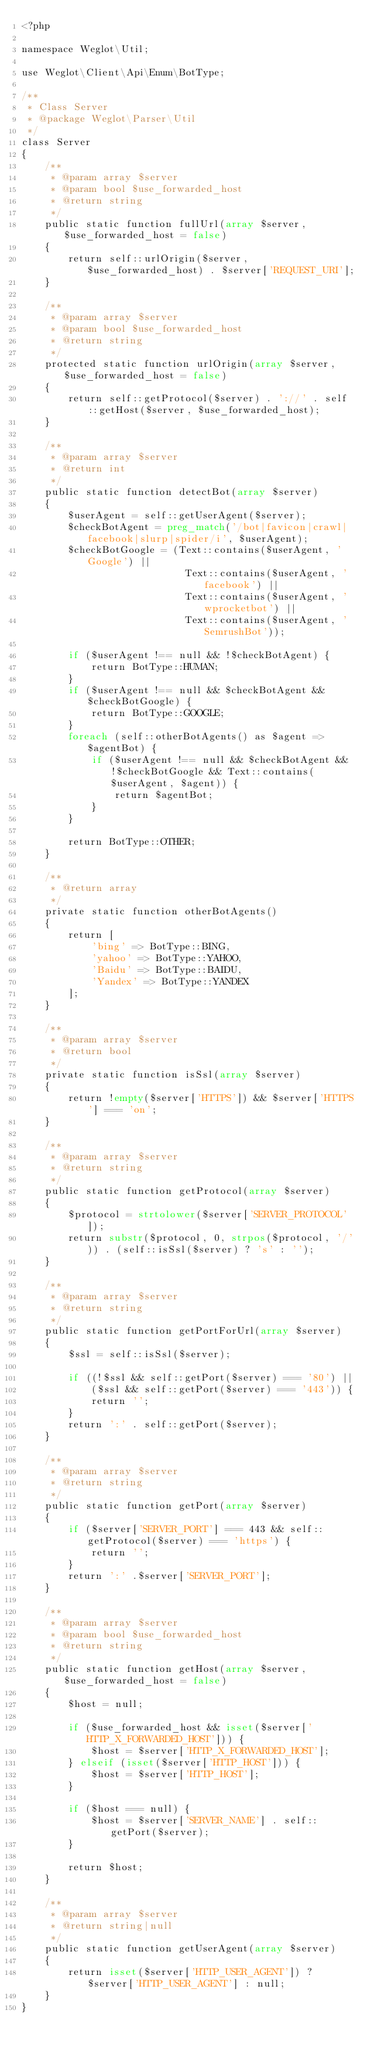Convert code to text. <code><loc_0><loc_0><loc_500><loc_500><_PHP_><?php

namespace Weglot\Util;

use Weglot\Client\Api\Enum\BotType;

/**
 * Class Server
 * @package Weglot\Parser\Util
 */
class Server
{
    /**
     * @param array $server
     * @param bool $use_forwarded_host
     * @return string
     */
    public static function fullUrl(array $server, $use_forwarded_host = false)
    {
        return self::urlOrigin($server, $use_forwarded_host) . $server['REQUEST_URI'];
    }

    /**
     * @param array $server
     * @param bool $use_forwarded_host
     * @return string
     */
    protected static function urlOrigin(array $server, $use_forwarded_host = false)
    {
        return self::getProtocol($server) . '://' . self::getHost($server, $use_forwarded_host);
    }

    /**
     * @param array $server
     * @return int
     */
    public static function detectBot(array $server)
    {
        $userAgent = self::getUserAgent($server);
        $checkBotAgent = preg_match('/bot|favicon|crawl|facebook|slurp|spider/i', $userAgent);
        $checkBotGoogle = (Text::contains($userAgent, 'Google') ||
                            Text::contains($userAgent, 'facebook') ||
                            Text::contains($userAgent, 'wprocketbot') ||
                            Text::contains($userAgent, 'SemrushBot'));
        
        if ($userAgent !== null && !$checkBotAgent) {
            return BotType::HUMAN;
        }
        if ($userAgent !== null && $checkBotAgent && $checkBotGoogle) {
            return BotType::GOOGLE;
        }
        foreach (self::otherBotAgents() as $agent => $agentBot) {
            if ($userAgent !== null && $checkBotAgent && !$checkBotGoogle && Text::contains($userAgent, $agent)) {
                return $agentBot;
            }
        }

        return BotType::OTHER;
    }

    /**
     * @return array
     */
    private static function otherBotAgents()
    {
        return [
            'bing' => BotType::BING,
            'yahoo' => BotType::YAHOO,
            'Baidu' => BotType::BAIDU,
            'Yandex' => BotType::YANDEX
        ];
    }

    /**
     * @param array $server
     * @return bool
     */
    private static function isSsl(array $server)
    {
        return !empty($server['HTTPS']) && $server['HTTPS'] === 'on';
    }

    /**
     * @param array $server
     * @return string
     */
    public static function getProtocol(array $server)
    {
        $protocol = strtolower($server['SERVER_PROTOCOL']);
        return substr($protocol, 0, strpos($protocol, '/')) . (self::isSsl($server) ? 's' : '');
    }

    /**
     * @param array $server
     * @return string
     */
    public static function getPortForUrl(array $server)
    {
        $ssl = self::isSsl($server);

        if ((!$ssl && self::getPort($server) === '80') ||
            ($ssl && self::getPort($server) === '443')) {
            return '';
        }
        return ':' . self::getPort($server);
    }

    /**
     * @param array $server
     * @return string
     */
    public static function getPort(array $server)
    {
        if ($server['SERVER_PORT'] === 443 && self::getProtocol($server) === 'https') {
            return '';
        }
        return ':' .$server['SERVER_PORT'];
    }

    /**
     * @param array $server
     * @param bool $use_forwarded_host
     * @return string
     */
    public static function getHost(array $server, $use_forwarded_host = false)
    {
        $host = null;

        if ($use_forwarded_host && isset($server['HTTP_X_FORWARDED_HOST'])) {
            $host = $server['HTTP_X_FORWARDED_HOST'];
        } elseif (isset($server['HTTP_HOST'])) {
            $host = $server['HTTP_HOST'];
        }

        if ($host === null) {
            $host = $server['SERVER_NAME'] . self::getPort($server);
        }

        return $host;
    }

    /**
     * @param array $server
     * @return string|null
     */
    public static function getUserAgent(array $server)
    {
        return isset($server['HTTP_USER_AGENT']) ? $server['HTTP_USER_AGENT'] : null;
    }
}
</code> 